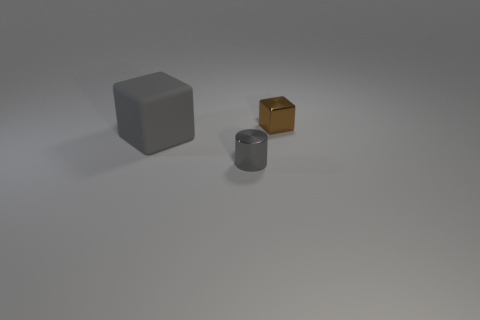Is there any other thing that is the same size as the gray matte block?
Provide a short and direct response. No. Are there the same number of rubber blocks that are to the left of the large block and tiny brown metallic things?
Ensure brevity in your answer.  No. The matte cube is what size?
Offer a very short reply. Large. How many tiny cylinders are behind the small object that is in front of the large object?
Your answer should be compact. 0. There is a object that is behind the gray metallic cylinder and on the right side of the large gray matte thing; what shape is it?
Give a very brief answer. Cube. What number of matte objects are the same color as the small metal cylinder?
Ensure brevity in your answer.  1. Are there any gray cylinders that are left of the object that is on the right side of the metallic thing to the left of the small brown thing?
Provide a short and direct response. Yes. What size is the object that is both behind the gray metal cylinder and in front of the brown thing?
Your answer should be very brief. Large. How many gray cylinders are the same material as the tiny block?
Offer a very short reply. 1. What number of blocks are gray metallic objects or large gray rubber objects?
Offer a terse response. 1. 